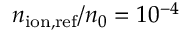<formula> <loc_0><loc_0><loc_500><loc_500>n _ { i o n , r e f } / n _ { 0 } = 1 0 ^ { - 4 }</formula> 